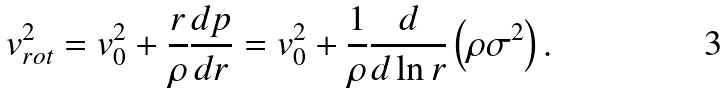<formula> <loc_0><loc_0><loc_500><loc_500>v _ { r o t } ^ { 2 } = v _ { 0 } ^ { 2 } + \frac { r } { \rho } \frac { d p } { d r } = v _ { 0 } ^ { 2 } + \frac { 1 } { \rho } \frac { d } { d \ln r } \left ( \rho \sigma ^ { 2 } \right ) .</formula> 